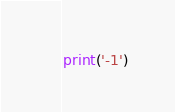Convert code to text. <code><loc_0><loc_0><loc_500><loc_500><_Python_>print('-1')</code> 